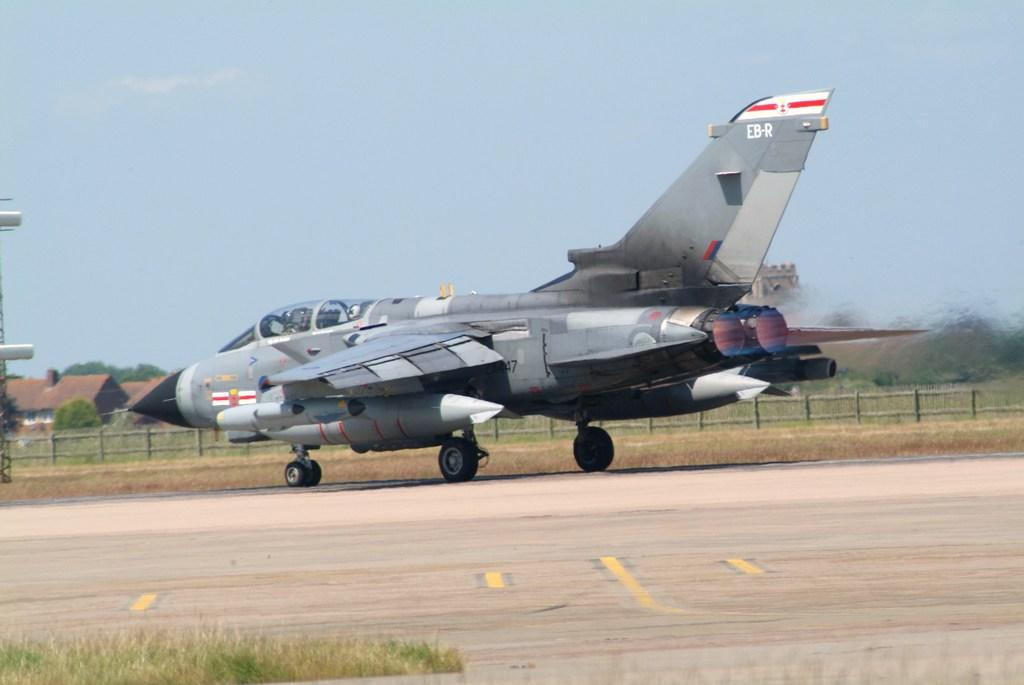What is the main subject in the middle of the image? There is an aircraft in the middle of the image. What can be seen in the background of the image? There are houses and trees in the background of the image. What is visible at the top of the image? The sky is visible at the top of the image. What type of vegetation is present at the bottom of the image? Grass is present at the bottom of the image. Can you see a yak grazing on the grass in the image? There is no yak present in the image; it features an aircraft, houses, trees, sky, and grass. Where is the stove located in the image? There is no stove present in the image. 